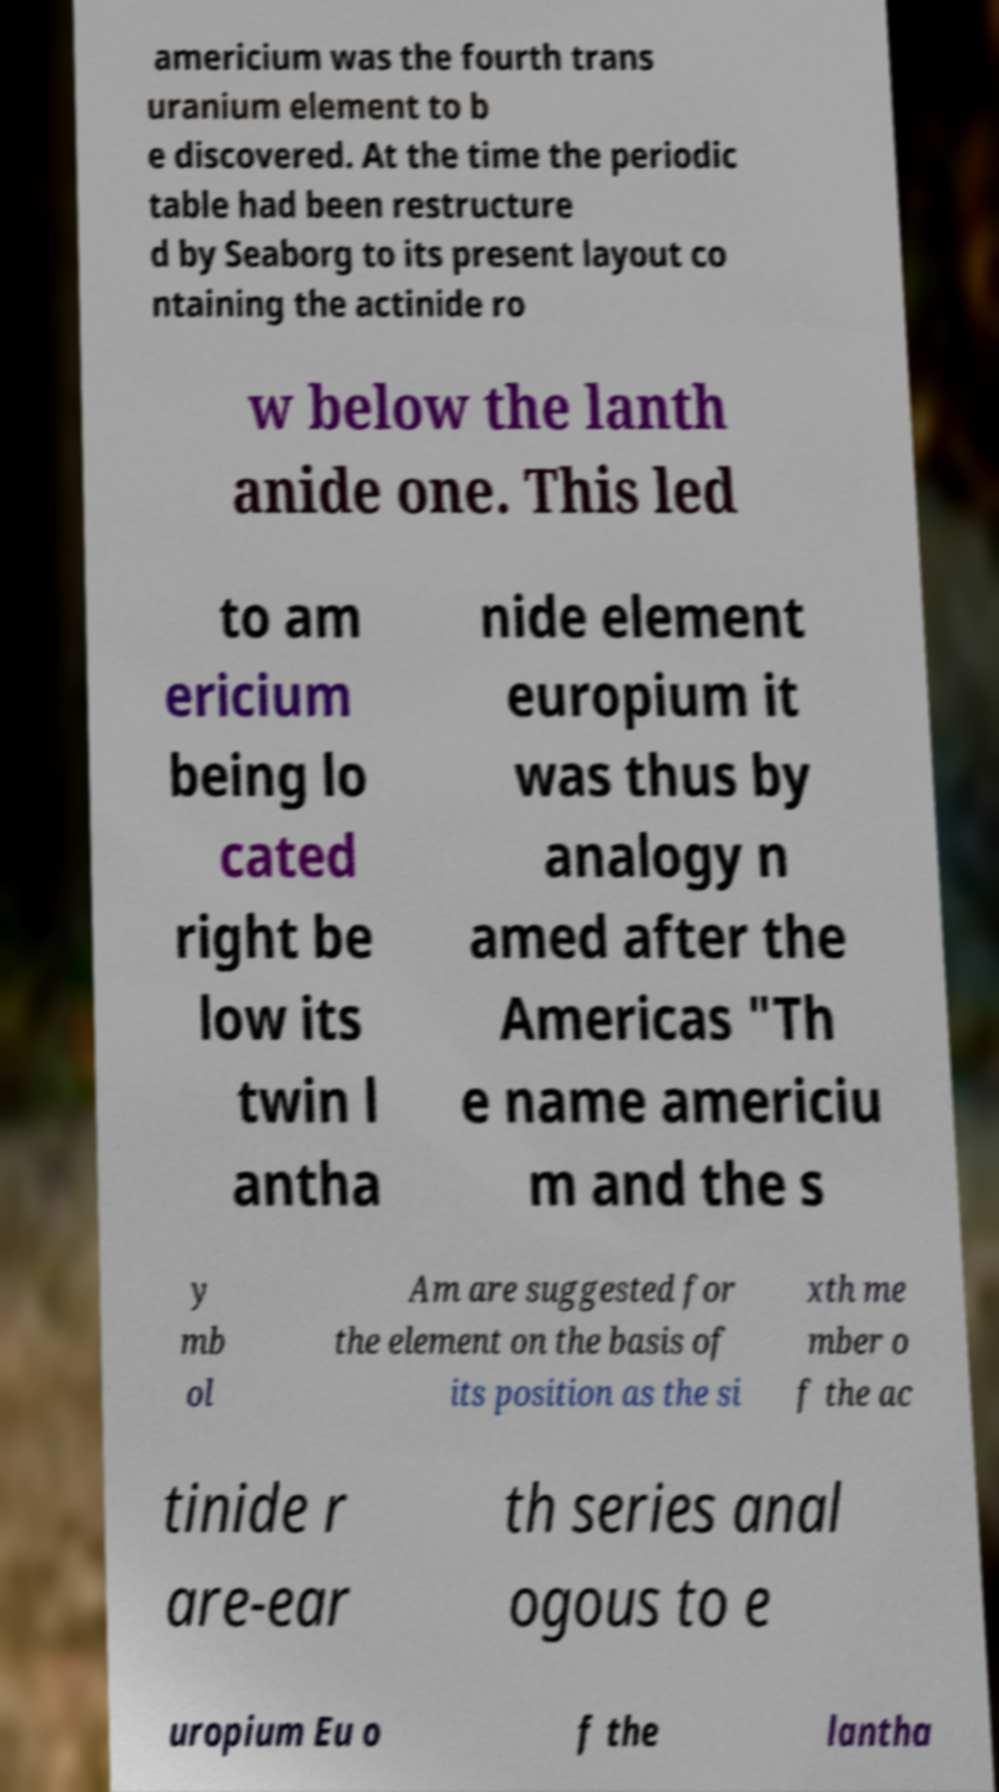Please identify and transcribe the text found in this image. americium was the fourth trans uranium element to b e discovered. At the time the periodic table had been restructure d by Seaborg to its present layout co ntaining the actinide ro w below the lanth anide one. This led to am ericium being lo cated right be low its twin l antha nide element europium it was thus by analogy n amed after the Americas "Th e name americiu m and the s y mb ol Am are suggested for the element on the basis of its position as the si xth me mber o f the ac tinide r are-ear th series anal ogous to e uropium Eu o f the lantha 